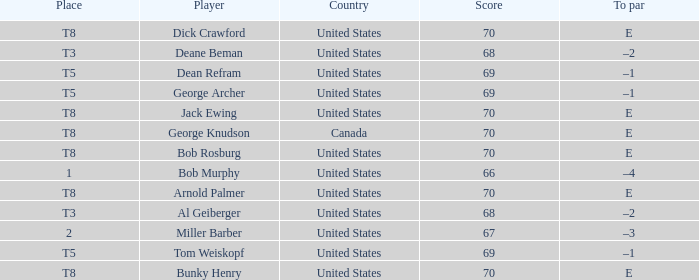When Bunky Henry placed t8, what was his To par? E. 